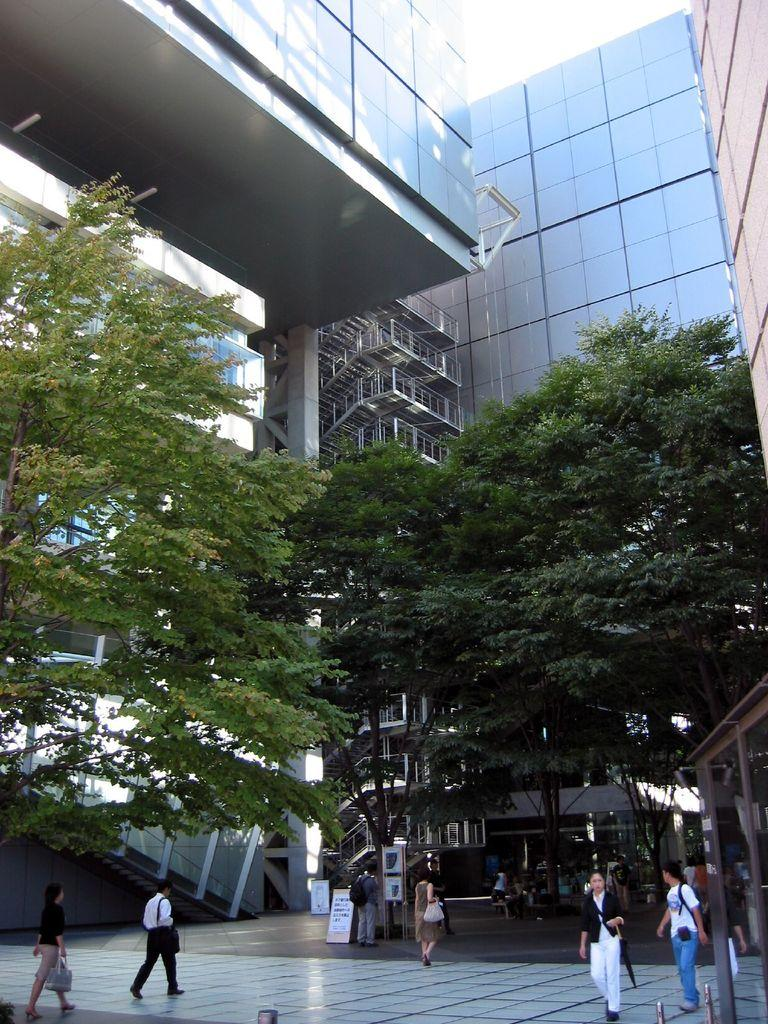What structure is the main subject of the image? There is a building in the image. What activity is taking place in front of the building? There are people walking in front of the building. What is visible at the top of the image? The sky is visible at the top of the image. How many crows can be seen sitting on the building in the image? There are no crows present in the image; it features a building and people walking in front of it. Is there a crown visible on the head of any person in the image? There is no crown visible on the head of any person in the image. 